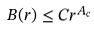<formula> <loc_0><loc_0><loc_500><loc_500>B ( r ) \leq C r ^ { A _ { c } }</formula> 